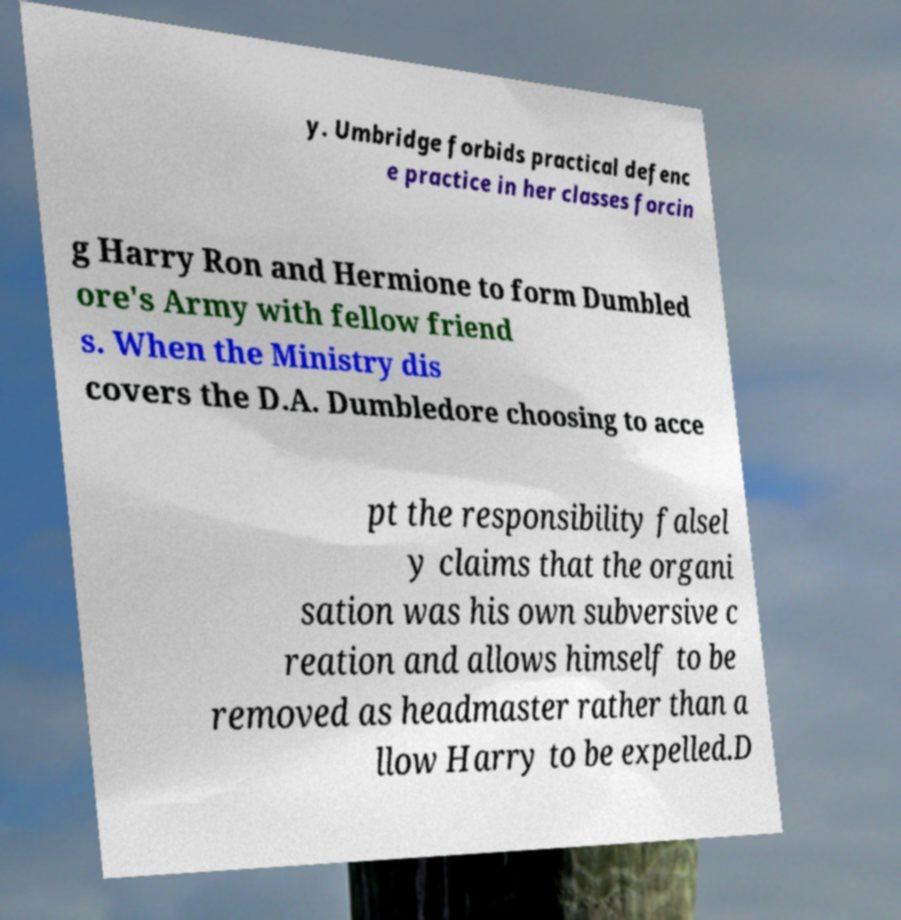There's text embedded in this image that I need extracted. Can you transcribe it verbatim? y. Umbridge forbids practical defenc e practice in her classes forcin g Harry Ron and Hermione to form Dumbled ore's Army with fellow friend s. When the Ministry dis covers the D.A. Dumbledore choosing to acce pt the responsibility falsel y claims that the organi sation was his own subversive c reation and allows himself to be removed as headmaster rather than a llow Harry to be expelled.D 